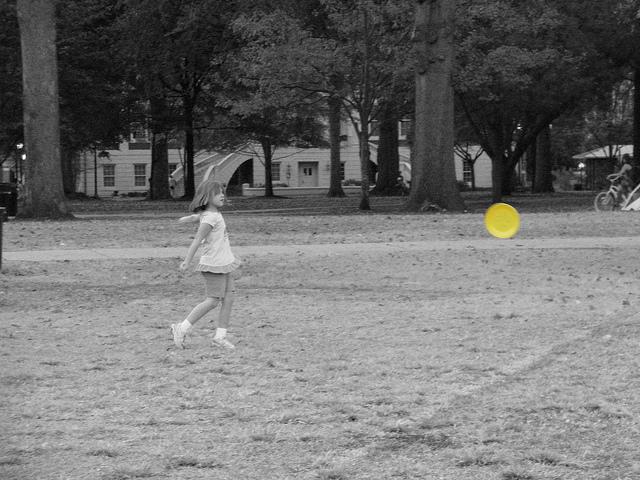Does this girl have on shorts?
Concise answer only. Yes. Is the girl wearing a pink dress?
Answer briefly. No. How many balls?
Keep it brief. 0. What is the yellow object?
Give a very brief answer. Frisbee. 